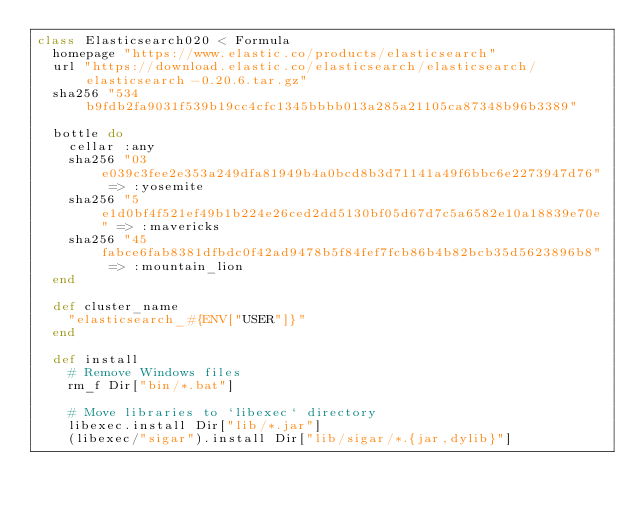Convert code to text. <code><loc_0><loc_0><loc_500><loc_500><_Ruby_>class Elasticsearch020 < Formula
  homepage "https://www.elastic.co/products/elasticsearch"
  url "https://download.elastic.co/elasticsearch/elasticsearch/elasticsearch-0.20.6.tar.gz"
  sha256 "534b9fdb2fa9031f539b19cc4cfc1345bbbb013a285a21105ca87348b96b3389"

  bottle do
    cellar :any
    sha256 "03e039c3fee2e353a249dfa81949b4a0bcd8b3d71141a49f6bbc6e2273947d76" => :yosemite
    sha256 "5e1d0bf4f521ef49b1b224e26ced2dd5130bf05d67d7c5a6582e10a18839e70e" => :mavericks
    sha256 "45fabce6fab8381dfbdc0f42ad9478b5f84fef7fcb86b4b82bcb35d5623896b8" => :mountain_lion
  end

  def cluster_name
    "elasticsearch_#{ENV["USER"]}"
  end

  def install
    # Remove Windows files
    rm_f Dir["bin/*.bat"]

    # Move libraries to `libexec` directory
    libexec.install Dir["lib/*.jar"]
    (libexec/"sigar").install Dir["lib/sigar/*.{jar,dylib}"]
</code> 